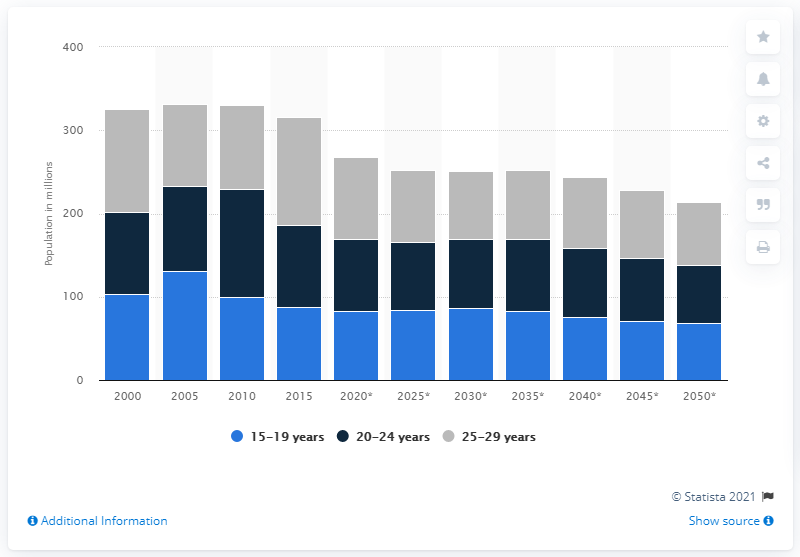Outline some significant characteristics in this image. In 2020, there will be approximately 97.99 people between the ages of 25 and 29. 